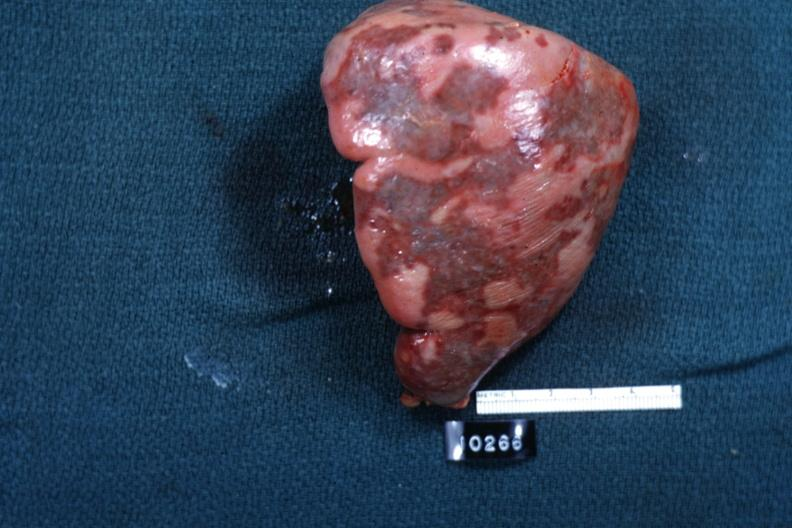what is slide?
Answer the question using a single word or phrase. Surface 